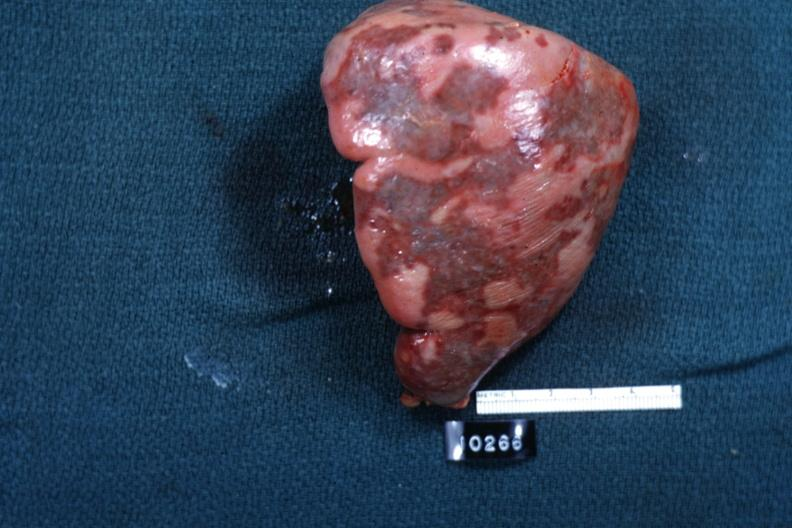what is slide?
Answer the question using a single word or phrase. Surface 